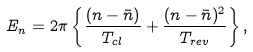Convert formula to latex. <formula><loc_0><loc_0><loc_500><loc_500>E _ { n } = 2 \pi \left \{ \frac { ( n - \bar { n } ) } { T _ { c l } } + \frac { ( n - \bar { n } ) ^ { 2 } } { T _ { r e v } } \right \} ,</formula> 